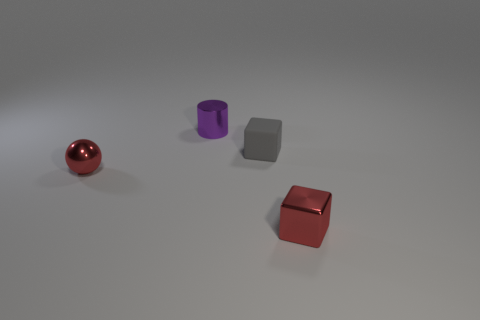There is a block that is left of the metallic thing that is to the right of the matte thing; what number of red objects are left of it? 1 